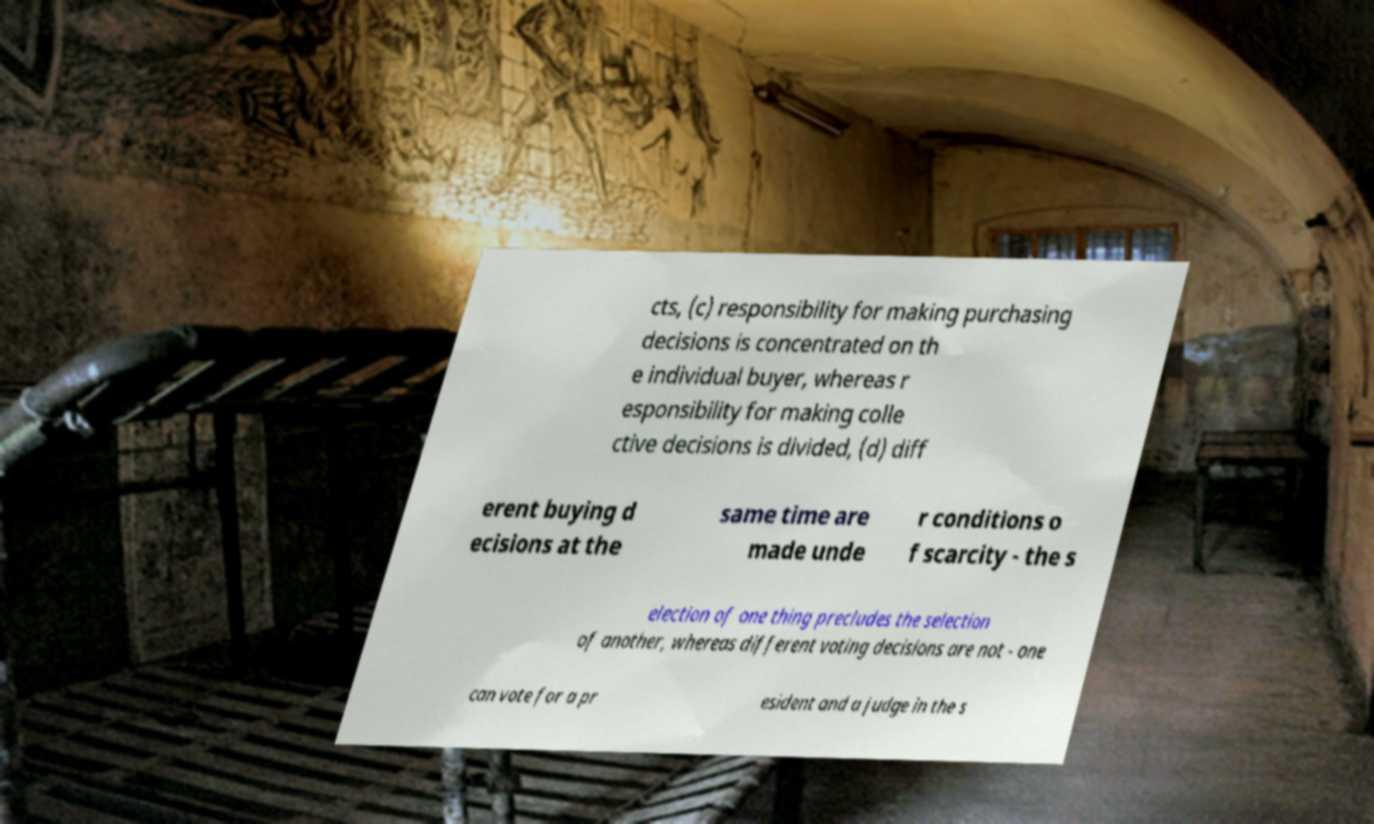Can you read and provide the text displayed in the image?This photo seems to have some interesting text. Can you extract and type it out for me? cts, (c) responsibility for making purchasing decisions is concentrated on th e individual buyer, whereas r esponsibility for making colle ctive decisions is divided, (d) diff erent buying d ecisions at the same time are made unde r conditions o f scarcity - the s election of one thing precludes the selection of another, whereas different voting decisions are not - one can vote for a pr esident and a judge in the s 